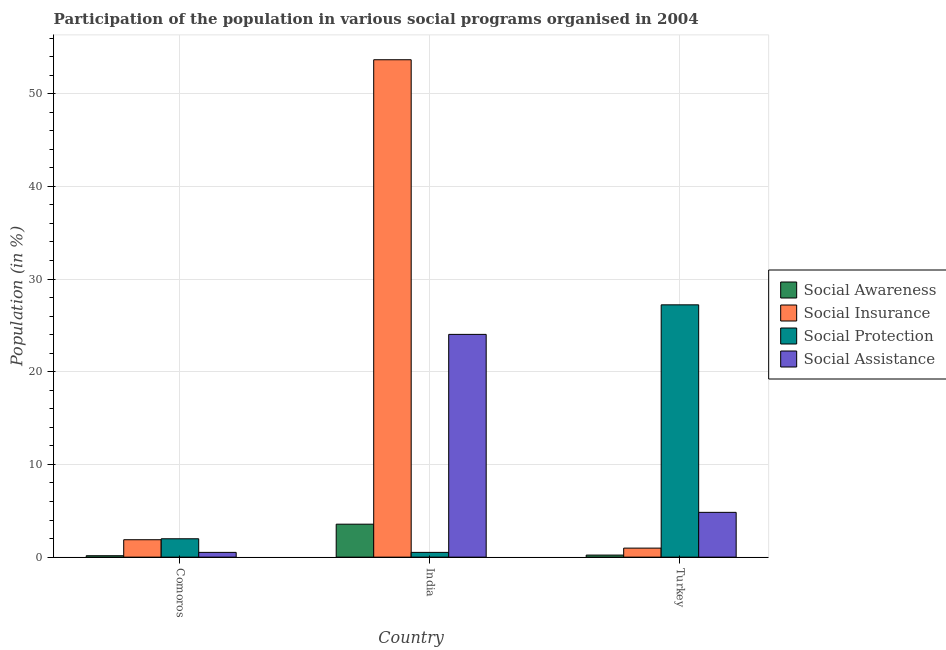How many different coloured bars are there?
Offer a very short reply. 4. Are the number of bars per tick equal to the number of legend labels?
Your answer should be very brief. Yes. How many bars are there on the 3rd tick from the left?
Give a very brief answer. 4. How many bars are there on the 1st tick from the right?
Offer a very short reply. 4. What is the label of the 1st group of bars from the left?
Provide a short and direct response. Comoros. What is the participation of population in social awareness programs in Comoros?
Your answer should be very brief. 0.15. Across all countries, what is the maximum participation of population in social insurance programs?
Your answer should be compact. 53.66. Across all countries, what is the minimum participation of population in social assistance programs?
Your response must be concise. 0.51. In which country was the participation of population in social assistance programs minimum?
Your answer should be very brief. Comoros. What is the total participation of population in social awareness programs in the graph?
Provide a short and direct response. 3.93. What is the difference between the participation of population in social awareness programs in Comoros and that in Turkey?
Offer a terse response. -0.07. What is the difference between the participation of population in social insurance programs in Comoros and the participation of population in social protection programs in India?
Give a very brief answer. 1.37. What is the average participation of population in social awareness programs per country?
Provide a succinct answer. 1.31. What is the difference between the participation of population in social assistance programs and participation of population in social awareness programs in Comoros?
Your answer should be compact. 0.36. What is the ratio of the participation of population in social assistance programs in Comoros to that in India?
Provide a short and direct response. 0.02. What is the difference between the highest and the second highest participation of population in social assistance programs?
Offer a terse response. 19.2. What is the difference between the highest and the lowest participation of population in social protection programs?
Make the answer very short. 26.71. In how many countries, is the participation of population in social awareness programs greater than the average participation of population in social awareness programs taken over all countries?
Ensure brevity in your answer.  1. Is the sum of the participation of population in social insurance programs in Comoros and Turkey greater than the maximum participation of population in social protection programs across all countries?
Your response must be concise. No. What does the 1st bar from the left in Comoros represents?
Provide a succinct answer. Social Awareness. What does the 2nd bar from the right in Turkey represents?
Provide a short and direct response. Social Protection. Is it the case that in every country, the sum of the participation of population in social awareness programs and participation of population in social insurance programs is greater than the participation of population in social protection programs?
Ensure brevity in your answer.  No. Are all the bars in the graph horizontal?
Ensure brevity in your answer.  No. How many countries are there in the graph?
Your answer should be compact. 3. What is the difference between two consecutive major ticks on the Y-axis?
Your answer should be very brief. 10. Are the values on the major ticks of Y-axis written in scientific E-notation?
Ensure brevity in your answer.  No. Does the graph contain grids?
Your answer should be very brief. Yes. Where does the legend appear in the graph?
Offer a terse response. Center right. How are the legend labels stacked?
Your answer should be compact. Vertical. What is the title of the graph?
Ensure brevity in your answer.  Participation of the population in various social programs organised in 2004. Does "Gender equality" appear as one of the legend labels in the graph?
Offer a very short reply. No. What is the label or title of the X-axis?
Keep it short and to the point. Country. What is the label or title of the Y-axis?
Give a very brief answer. Population (in %). What is the Population (in %) of Social Awareness in Comoros?
Give a very brief answer. 0.15. What is the Population (in %) of Social Insurance in Comoros?
Keep it short and to the point. 1.88. What is the Population (in %) of Social Protection in Comoros?
Provide a short and direct response. 1.98. What is the Population (in %) in Social Assistance in Comoros?
Your answer should be very brief. 0.51. What is the Population (in %) in Social Awareness in India?
Offer a very short reply. 3.56. What is the Population (in %) of Social Insurance in India?
Your response must be concise. 53.66. What is the Population (in %) of Social Protection in India?
Offer a terse response. 0.51. What is the Population (in %) in Social Assistance in India?
Provide a succinct answer. 24.03. What is the Population (in %) of Social Awareness in Turkey?
Keep it short and to the point. 0.22. What is the Population (in %) of Social Insurance in Turkey?
Your answer should be compact. 0.97. What is the Population (in %) in Social Protection in Turkey?
Your answer should be very brief. 27.22. What is the Population (in %) in Social Assistance in Turkey?
Offer a very short reply. 4.83. Across all countries, what is the maximum Population (in %) of Social Awareness?
Give a very brief answer. 3.56. Across all countries, what is the maximum Population (in %) of Social Insurance?
Give a very brief answer. 53.66. Across all countries, what is the maximum Population (in %) in Social Protection?
Your answer should be compact. 27.22. Across all countries, what is the maximum Population (in %) in Social Assistance?
Your response must be concise. 24.03. Across all countries, what is the minimum Population (in %) of Social Awareness?
Provide a short and direct response. 0.15. Across all countries, what is the minimum Population (in %) of Social Insurance?
Make the answer very short. 0.97. Across all countries, what is the minimum Population (in %) in Social Protection?
Offer a very short reply. 0.51. Across all countries, what is the minimum Population (in %) in Social Assistance?
Offer a terse response. 0.51. What is the total Population (in %) in Social Awareness in the graph?
Your response must be concise. 3.93. What is the total Population (in %) of Social Insurance in the graph?
Ensure brevity in your answer.  56.52. What is the total Population (in %) in Social Protection in the graph?
Offer a very short reply. 29.72. What is the total Population (in %) of Social Assistance in the graph?
Provide a succinct answer. 29.38. What is the difference between the Population (in %) in Social Awareness in Comoros and that in India?
Offer a terse response. -3.4. What is the difference between the Population (in %) of Social Insurance in Comoros and that in India?
Provide a succinct answer. -51.78. What is the difference between the Population (in %) in Social Protection in Comoros and that in India?
Provide a short and direct response. 1.47. What is the difference between the Population (in %) in Social Assistance in Comoros and that in India?
Your response must be concise. -23.52. What is the difference between the Population (in %) of Social Awareness in Comoros and that in Turkey?
Provide a succinct answer. -0.07. What is the difference between the Population (in %) in Social Insurance in Comoros and that in Turkey?
Make the answer very short. 0.91. What is the difference between the Population (in %) of Social Protection in Comoros and that in Turkey?
Offer a very short reply. -25.24. What is the difference between the Population (in %) in Social Assistance in Comoros and that in Turkey?
Provide a succinct answer. -4.32. What is the difference between the Population (in %) of Social Awareness in India and that in Turkey?
Your answer should be very brief. 3.33. What is the difference between the Population (in %) in Social Insurance in India and that in Turkey?
Your answer should be very brief. 52.69. What is the difference between the Population (in %) of Social Protection in India and that in Turkey?
Make the answer very short. -26.71. What is the difference between the Population (in %) of Social Assistance in India and that in Turkey?
Offer a very short reply. 19.2. What is the difference between the Population (in %) of Social Awareness in Comoros and the Population (in %) of Social Insurance in India?
Your answer should be very brief. -53.51. What is the difference between the Population (in %) of Social Awareness in Comoros and the Population (in %) of Social Protection in India?
Keep it short and to the point. -0.36. What is the difference between the Population (in %) of Social Awareness in Comoros and the Population (in %) of Social Assistance in India?
Offer a very short reply. -23.88. What is the difference between the Population (in %) of Social Insurance in Comoros and the Population (in %) of Social Protection in India?
Your response must be concise. 1.37. What is the difference between the Population (in %) of Social Insurance in Comoros and the Population (in %) of Social Assistance in India?
Your answer should be compact. -22.15. What is the difference between the Population (in %) of Social Protection in Comoros and the Population (in %) of Social Assistance in India?
Provide a succinct answer. -22.05. What is the difference between the Population (in %) in Social Awareness in Comoros and the Population (in %) in Social Insurance in Turkey?
Your response must be concise. -0.82. What is the difference between the Population (in %) in Social Awareness in Comoros and the Population (in %) in Social Protection in Turkey?
Give a very brief answer. -27.07. What is the difference between the Population (in %) of Social Awareness in Comoros and the Population (in %) of Social Assistance in Turkey?
Provide a succinct answer. -4.68. What is the difference between the Population (in %) in Social Insurance in Comoros and the Population (in %) in Social Protection in Turkey?
Provide a succinct answer. -25.34. What is the difference between the Population (in %) of Social Insurance in Comoros and the Population (in %) of Social Assistance in Turkey?
Ensure brevity in your answer.  -2.95. What is the difference between the Population (in %) of Social Protection in Comoros and the Population (in %) of Social Assistance in Turkey?
Give a very brief answer. -2.85. What is the difference between the Population (in %) in Social Awareness in India and the Population (in %) in Social Insurance in Turkey?
Give a very brief answer. 2.58. What is the difference between the Population (in %) in Social Awareness in India and the Population (in %) in Social Protection in Turkey?
Ensure brevity in your answer.  -23.66. What is the difference between the Population (in %) in Social Awareness in India and the Population (in %) in Social Assistance in Turkey?
Keep it short and to the point. -1.28. What is the difference between the Population (in %) of Social Insurance in India and the Population (in %) of Social Protection in Turkey?
Your answer should be very brief. 26.44. What is the difference between the Population (in %) of Social Insurance in India and the Population (in %) of Social Assistance in Turkey?
Your response must be concise. 48.83. What is the difference between the Population (in %) of Social Protection in India and the Population (in %) of Social Assistance in Turkey?
Your response must be concise. -4.32. What is the average Population (in %) of Social Awareness per country?
Your response must be concise. 1.31. What is the average Population (in %) of Social Insurance per country?
Your response must be concise. 18.84. What is the average Population (in %) in Social Protection per country?
Your answer should be very brief. 9.91. What is the average Population (in %) in Social Assistance per country?
Make the answer very short. 9.79. What is the difference between the Population (in %) in Social Awareness and Population (in %) in Social Insurance in Comoros?
Make the answer very short. -1.73. What is the difference between the Population (in %) in Social Awareness and Population (in %) in Social Protection in Comoros?
Make the answer very short. -1.83. What is the difference between the Population (in %) of Social Awareness and Population (in %) of Social Assistance in Comoros?
Your answer should be very brief. -0.36. What is the difference between the Population (in %) in Social Insurance and Population (in %) in Social Protection in Comoros?
Your answer should be very brief. -0.1. What is the difference between the Population (in %) in Social Insurance and Population (in %) in Social Assistance in Comoros?
Offer a very short reply. 1.37. What is the difference between the Population (in %) of Social Protection and Population (in %) of Social Assistance in Comoros?
Keep it short and to the point. 1.47. What is the difference between the Population (in %) in Social Awareness and Population (in %) in Social Insurance in India?
Ensure brevity in your answer.  -50.1. What is the difference between the Population (in %) in Social Awareness and Population (in %) in Social Protection in India?
Give a very brief answer. 3.04. What is the difference between the Population (in %) in Social Awareness and Population (in %) in Social Assistance in India?
Your answer should be compact. -20.47. What is the difference between the Population (in %) of Social Insurance and Population (in %) of Social Protection in India?
Provide a succinct answer. 53.15. What is the difference between the Population (in %) of Social Insurance and Population (in %) of Social Assistance in India?
Ensure brevity in your answer.  29.63. What is the difference between the Population (in %) of Social Protection and Population (in %) of Social Assistance in India?
Your response must be concise. -23.52. What is the difference between the Population (in %) in Social Awareness and Population (in %) in Social Insurance in Turkey?
Keep it short and to the point. -0.75. What is the difference between the Population (in %) of Social Awareness and Population (in %) of Social Protection in Turkey?
Your answer should be very brief. -27. What is the difference between the Population (in %) of Social Awareness and Population (in %) of Social Assistance in Turkey?
Your answer should be compact. -4.61. What is the difference between the Population (in %) of Social Insurance and Population (in %) of Social Protection in Turkey?
Give a very brief answer. -26.25. What is the difference between the Population (in %) in Social Insurance and Population (in %) in Social Assistance in Turkey?
Provide a succinct answer. -3.86. What is the difference between the Population (in %) in Social Protection and Population (in %) in Social Assistance in Turkey?
Provide a succinct answer. 22.39. What is the ratio of the Population (in %) of Social Awareness in Comoros to that in India?
Offer a terse response. 0.04. What is the ratio of the Population (in %) of Social Insurance in Comoros to that in India?
Offer a terse response. 0.04. What is the ratio of the Population (in %) of Social Protection in Comoros to that in India?
Your answer should be compact. 3.85. What is the ratio of the Population (in %) in Social Assistance in Comoros to that in India?
Give a very brief answer. 0.02. What is the ratio of the Population (in %) of Social Awareness in Comoros to that in Turkey?
Offer a terse response. 0.69. What is the ratio of the Population (in %) in Social Insurance in Comoros to that in Turkey?
Your response must be concise. 1.93. What is the ratio of the Population (in %) in Social Protection in Comoros to that in Turkey?
Offer a very short reply. 0.07. What is the ratio of the Population (in %) of Social Assistance in Comoros to that in Turkey?
Your response must be concise. 0.11. What is the ratio of the Population (in %) in Social Awareness in India to that in Turkey?
Provide a succinct answer. 15.95. What is the ratio of the Population (in %) in Social Insurance in India to that in Turkey?
Keep it short and to the point. 55.09. What is the ratio of the Population (in %) in Social Protection in India to that in Turkey?
Offer a terse response. 0.02. What is the ratio of the Population (in %) in Social Assistance in India to that in Turkey?
Offer a very short reply. 4.97. What is the difference between the highest and the second highest Population (in %) in Social Awareness?
Your answer should be compact. 3.33. What is the difference between the highest and the second highest Population (in %) in Social Insurance?
Give a very brief answer. 51.78. What is the difference between the highest and the second highest Population (in %) in Social Protection?
Ensure brevity in your answer.  25.24. What is the difference between the highest and the second highest Population (in %) of Social Assistance?
Provide a succinct answer. 19.2. What is the difference between the highest and the lowest Population (in %) of Social Awareness?
Make the answer very short. 3.4. What is the difference between the highest and the lowest Population (in %) in Social Insurance?
Keep it short and to the point. 52.69. What is the difference between the highest and the lowest Population (in %) of Social Protection?
Give a very brief answer. 26.71. What is the difference between the highest and the lowest Population (in %) in Social Assistance?
Offer a very short reply. 23.52. 